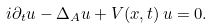Convert formula to latex. <formula><loc_0><loc_0><loc_500><loc_500>i \partial _ { t } u - \Delta _ { A } u + V ( x , t ) \, u = 0 .</formula> 